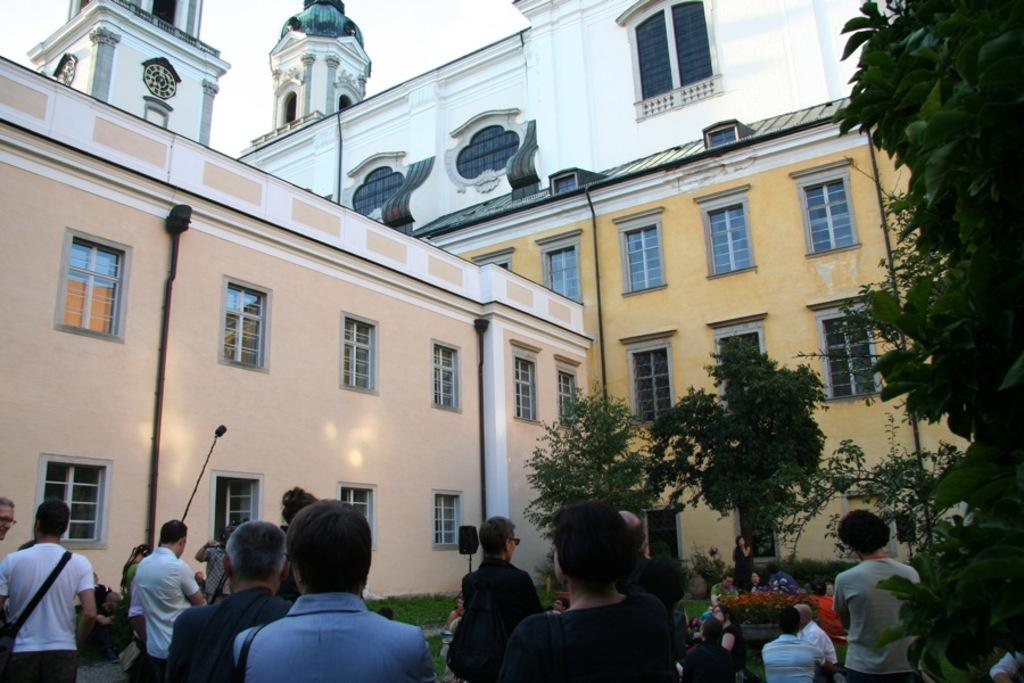How many people are in the image? There is a group of people in the image, but the exact number is not specified. What are the people in the image doing? Some people are sitting, while others are standing. What can be seen in the image besides the people? There are speakers, trees, buildings with windows, and the sky visible in the background. What type of gold cloth is draped over the learning materials in the image? There is no gold cloth or learning materials present in the image. 